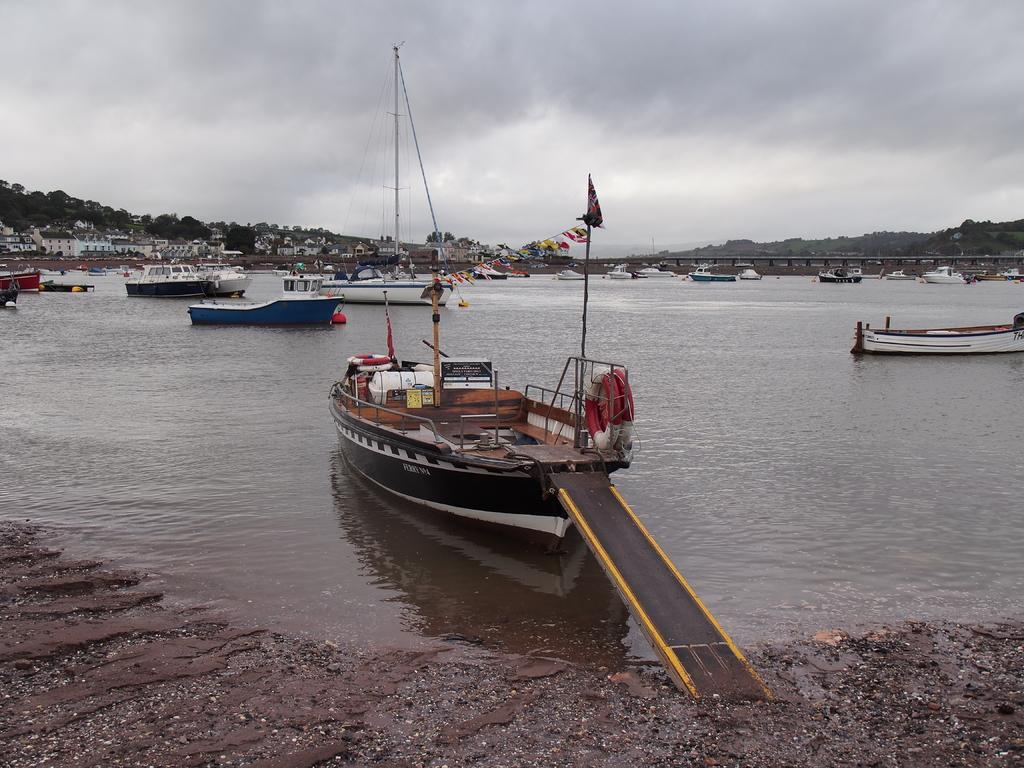What is in the water in the image? There are boats in the water in the image. What can be seen in the background of the image? There are trees and buildings in the background of the image. What structure might be connecting the two sides of the water? The image appears to depict a bridge. What is visible in the sky in the image? Clouds are visible in the sky in the image. What is the price of the guide for the boats in the image? There is no guide or price mentioned in the image; it only shows boats in the water, trees and buildings in the background, a bridge, and clouds in the sky. 